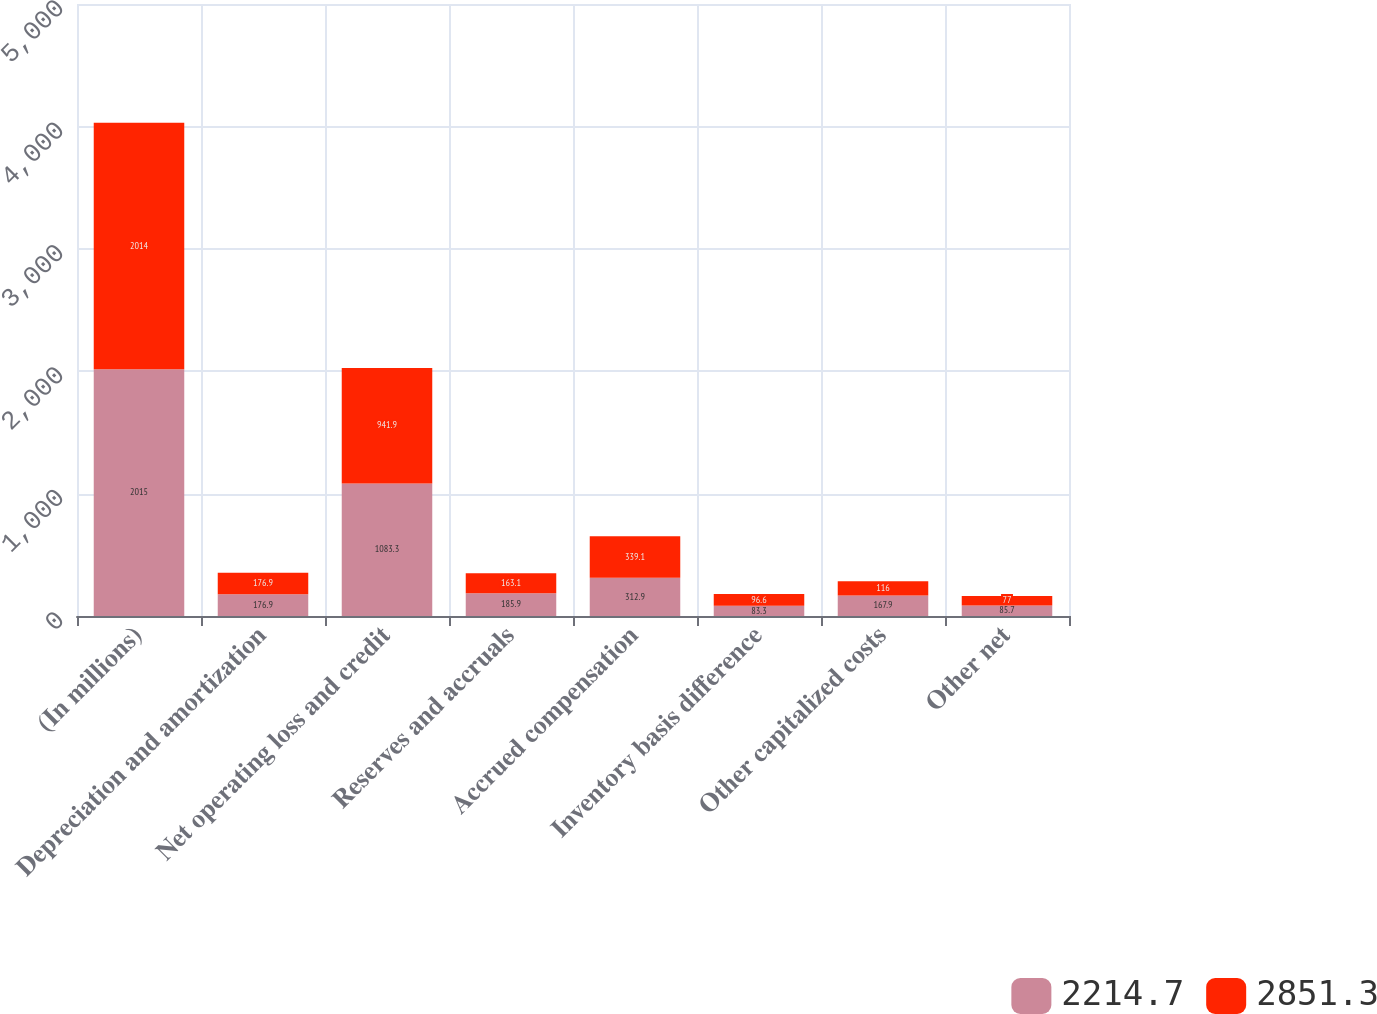Convert chart to OTSL. <chart><loc_0><loc_0><loc_500><loc_500><stacked_bar_chart><ecel><fcel>(In millions)<fcel>Depreciation and amortization<fcel>Net operating loss and credit<fcel>Reserves and accruals<fcel>Accrued compensation<fcel>Inventory basis difference<fcel>Other capitalized costs<fcel>Other net<nl><fcel>2214.7<fcel>2015<fcel>176.9<fcel>1083.3<fcel>185.9<fcel>312.9<fcel>83.3<fcel>167.9<fcel>85.7<nl><fcel>2851.3<fcel>2014<fcel>176.9<fcel>941.9<fcel>163.1<fcel>339.1<fcel>96.6<fcel>116<fcel>77<nl></chart> 